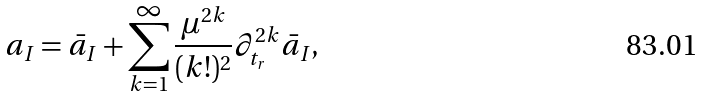Convert formula to latex. <formula><loc_0><loc_0><loc_500><loc_500>a _ { I } = \bar { a } _ { I } + \sum _ { k = 1 } ^ { \infty } { \frac { \mu ^ { 2 k } } { ( k ! ) ^ { 2 } } } \partial _ { t _ { r } } ^ { 2 k } \bar { a } _ { I } ,</formula> 